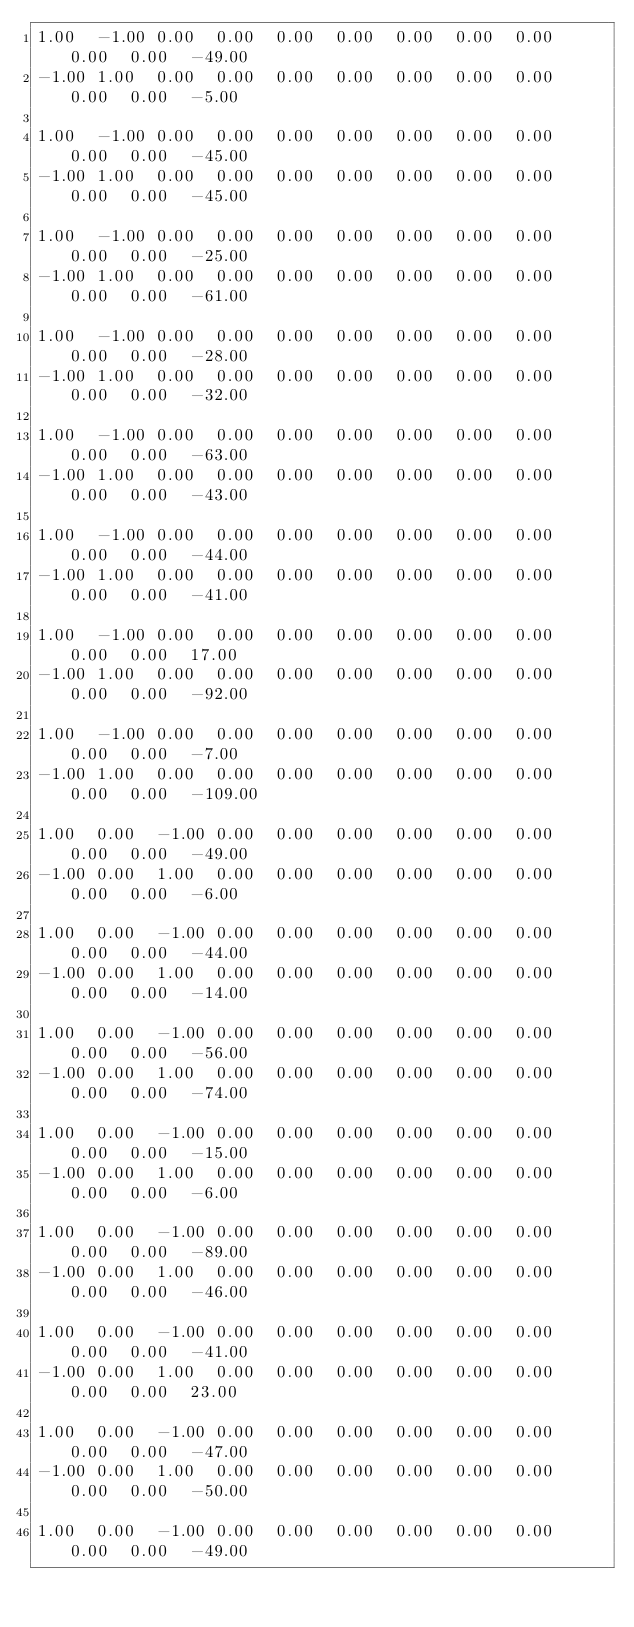<code> <loc_0><loc_0><loc_500><loc_500><_Matlab_>1.00	-1.00	0.00	0.00	0.00	0.00	0.00	0.00	0.00	0.00	0.00	-49.00
-1.00	1.00	0.00	0.00	0.00	0.00	0.00	0.00	0.00	0.00	0.00	-5.00

1.00	-1.00	0.00	0.00	0.00	0.00	0.00	0.00	0.00	0.00	0.00	-45.00
-1.00	1.00	0.00	0.00	0.00	0.00	0.00	0.00	0.00	0.00	0.00	-45.00

1.00	-1.00	0.00	0.00	0.00	0.00	0.00	0.00	0.00	0.00	0.00	-25.00
-1.00	1.00	0.00	0.00	0.00	0.00	0.00	0.00	0.00	0.00	0.00	-61.00

1.00	-1.00	0.00	0.00	0.00	0.00	0.00	0.00	0.00	0.00	0.00	-28.00
-1.00	1.00	0.00	0.00	0.00	0.00	0.00	0.00	0.00	0.00	0.00	-32.00

1.00	-1.00	0.00	0.00	0.00	0.00	0.00	0.00	0.00	0.00	0.00	-63.00
-1.00	1.00	0.00	0.00	0.00	0.00	0.00	0.00	0.00	0.00	0.00	-43.00

1.00	-1.00	0.00	0.00	0.00	0.00	0.00	0.00	0.00	0.00	0.00	-44.00
-1.00	1.00	0.00	0.00	0.00	0.00	0.00	0.00	0.00	0.00	0.00	-41.00

1.00	-1.00	0.00	0.00	0.00	0.00	0.00	0.00	0.00	0.00	0.00	17.00
-1.00	1.00	0.00	0.00	0.00	0.00	0.00	0.00	0.00	0.00	0.00	-92.00

1.00	-1.00	0.00	0.00	0.00	0.00	0.00	0.00	0.00	0.00	0.00	-7.00
-1.00	1.00	0.00	0.00	0.00	0.00	0.00	0.00	0.00	0.00	0.00	-109.00

1.00	0.00	-1.00	0.00	0.00	0.00	0.00	0.00	0.00	0.00	0.00	-49.00
-1.00	0.00	1.00	0.00	0.00	0.00	0.00	0.00	0.00	0.00	0.00	-6.00

1.00	0.00	-1.00	0.00	0.00	0.00	0.00	0.00	0.00	0.00	0.00	-44.00
-1.00	0.00	1.00	0.00	0.00	0.00	0.00	0.00	0.00	0.00	0.00	-14.00

1.00	0.00	-1.00	0.00	0.00	0.00	0.00	0.00	0.00	0.00	0.00	-56.00
-1.00	0.00	1.00	0.00	0.00	0.00	0.00	0.00	0.00	0.00	0.00	-74.00

1.00	0.00	-1.00	0.00	0.00	0.00	0.00	0.00	0.00	0.00	0.00	-15.00
-1.00	0.00	1.00	0.00	0.00	0.00	0.00	0.00	0.00	0.00	0.00	-6.00

1.00	0.00	-1.00	0.00	0.00	0.00	0.00	0.00	0.00	0.00	0.00	-89.00
-1.00	0.00	1.00	0.00	0.00	0.00	0.00	0.00	0.00	0.00	0.00	-46.00

1.00	0.00	-1.00	0.00	0.00	0.00	0.00	0.00	0.00	0.00	0.00	-41.00
-1.00	0.00	1.00	0.00	0.00	0.00	0.00	0.00	0.00	0.00	0.00	23.00

1.00	0.00	-1.00	0.00	0.00	0.00	0.00	0.00	0.00	0.00	0.00	-47.00
-1.00	0.00	1.00	0.00	0.00	0.00	0.00	0.00	0.00	0.00	0.00	-50.00

1.00	0.00	-1.00	0.00	0.00	0.00	0.00	0.00	0.00	0.00	0.00	-49.00</code> 